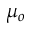<formula> <loc_0><loc_0><loc_500><loc_500>\mu _ { o }</formula> 